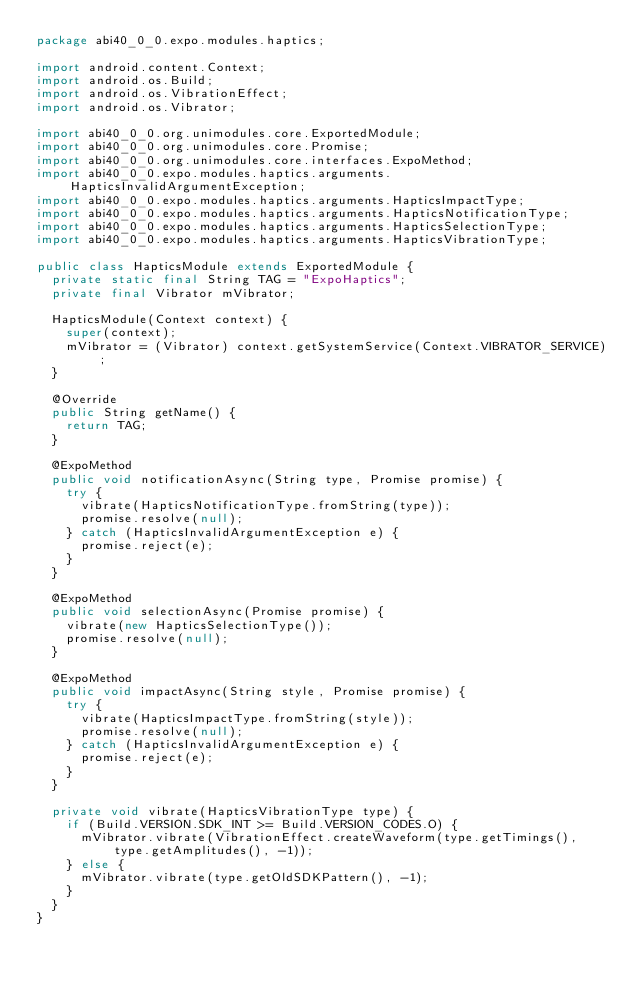<code> <loc_0><loc_0><loc_500><loc_500><_Java_>package abi40_0_0.expo.modules.haptics;

import android.content.Context;
import android.os.Build;
import android.os.VibrationEffect;
import android.os.Vibrator;

import abi40_0_0.org.unimodules.core.ExportedModule;
import abi40_0_0.org.unimodules.core.Promise;
import abi40_0_0.org.unimodules.core.interfaces.ExpoMethod;
import abi40_0_0.expo.modules.haptics.arguments.HapticsInvalidArgumentException;
import abi40_0_0.expo.modules.haptics.arguments.HapticsImpactType;
import abi40_0_0.expo.modules.haptics.arguments.HapticsNotificationType;
import abi40_0_0.expo.modules.haptics.arguments.HapticsSelectionType;
import abi40_0_0.expo.modules.haptics.arguments.HapticsVibrationType;

public class HapticsModule extends ExportedModule {
  private static final String TAG = "ExpoHaptics";
  private final Vibrator mVibrator;

  HapticsModule(Context context) {
    super(context);
    mVibrator = (Vibrator) context.getSystemService(Context.VIBRATOR_SERVICE);
  }

  @Override
  public String getName() {
    return TAG;
  }

  @ExpoMethod
  public void notificationAsync(String type, Promise promise) {
    try {
      vibrate(HapticsNotificationType.fromString(type));
      promise.resolve(null);
    } catch (HapticsInvalidArgumentException e) {
      promise.reject(e);
    }
  }

  @ExpoMethod
  public void selectionAsync(Promise promise) {
    vibrate(new HapticsSelectionType());
    promise.resolve(null);
  }

  @ExpoMethod
  public void impactAsync(String style, Promise promise) {
    try {
      vibrate(HapticsImpactType.fromString(style));
      promise.resolve(null);
    } catch (HapticsInvalidArgumentException e) {
      promise.reject(e);
    }
  }

  private void vibrate(HapticsVibrationType type) {
    if (Build.VERSION.SDK_INT >= Build.VERSION_CODES.O) {
      mVibrator.vibrate(VibrationEffect.createWaveform(type.getTimings(), type.getAmplitudes(), -1));
    } else {
      mVibrator.vibrate(type.getOldSDKPattern(), -1);
    }
  }
}
</code> 